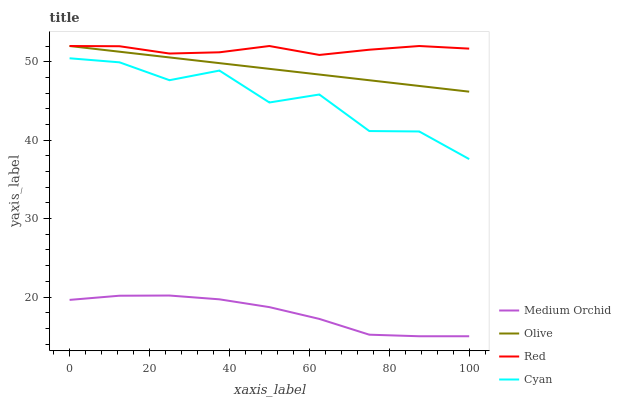Does Medium Orchid have the minimum area under the curve?
Answer yes or no. Yes. Does Red have the maximum area under the curve?
Answer yes or no. Yes. Does Cyan have the minimum area under the curve?
Answer yes or no. No. Does Cyan have the maximum area under the curve?
Answer yes or no. No. Is Olive the smoothest?
Answer yes or no. Yes. Is Cyan the roughest?
Answer yes or no. Yes. Is Medium Orchid the smoothest?
Answer yes or no. No. Is Medium Orchid the roughest?
Answer yes or no. No. Does Medium Orchid have the lowest value?
Answer yes or no. Yes. Does Cyan have the lowest value?
Answer yes or no. No. Does Red have the highest value?
Answer yes or no. Yes. Does Cyan have the highest value?
Answer yes or no. No. Is Cyan less than Red?
Answer yes or no. Yes. Is Olive greater than Medium Orchid?
Answer yes or no. Yes. Does Red intersect Olive?
Answer yes or no. Yes. Is Red less than Olive?
Answer yes or no. No. Is Red greater than Olive?
Answer yes or no. No. Does Cyan intersect Red?
Answer yes or no. No. 